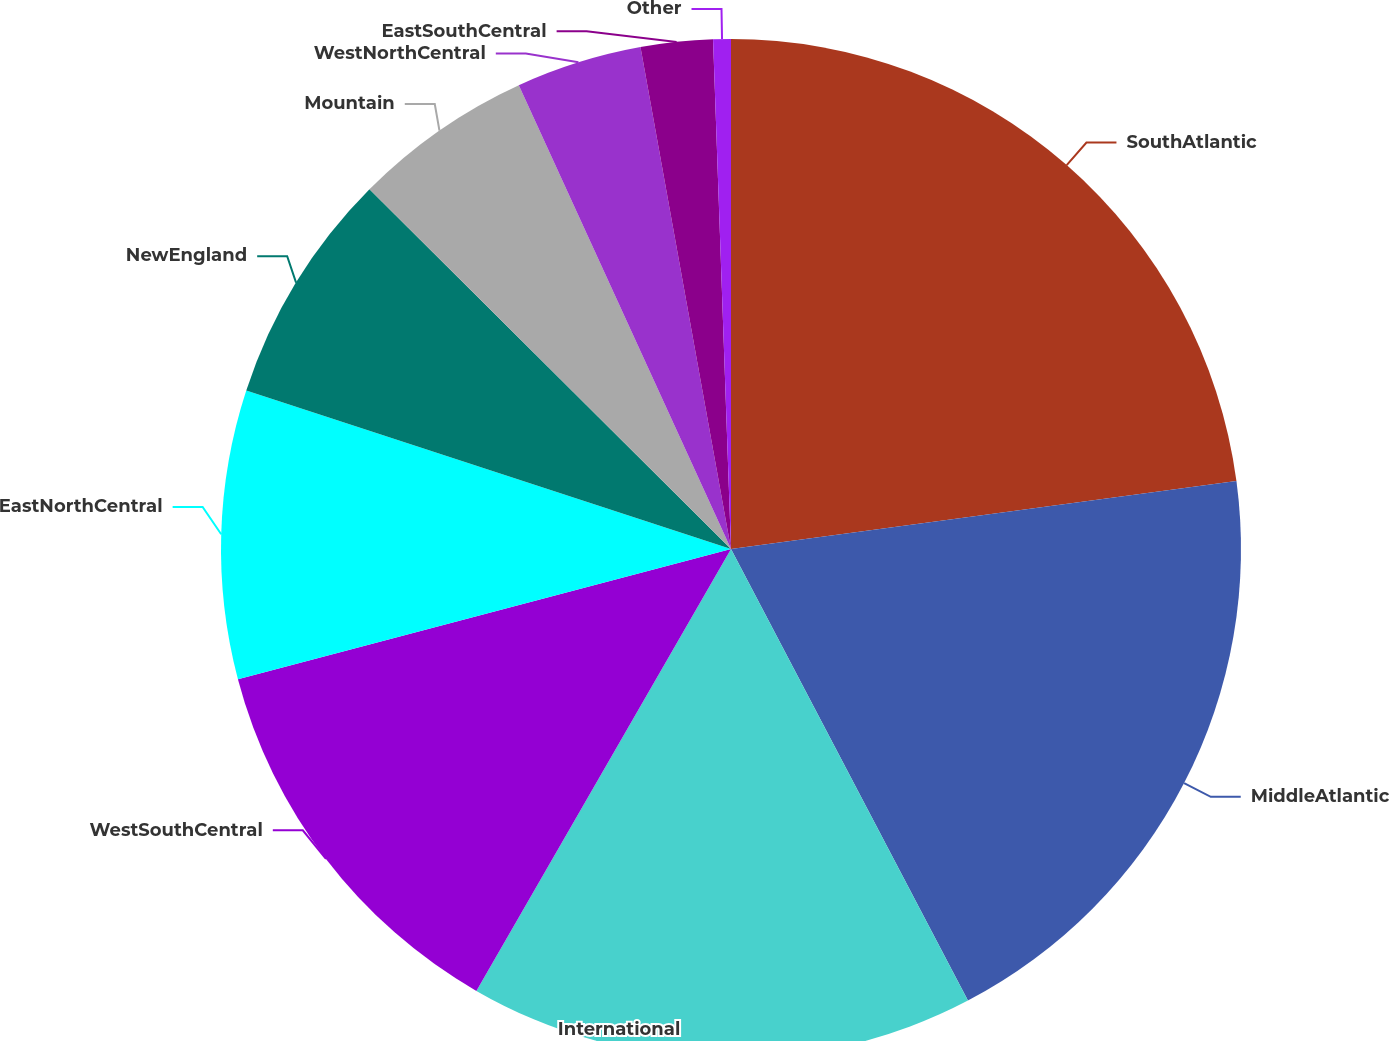<chart> <loc_0><loc_0><loc_500><loc_500><pie_chart><fcel>SouthAtlantic<fcel>MiddleAtlantic<fcel>International<fcel>WestSouthCentral<fcel>EastNorthCentral<fcel>NewEngland<fcel>Mountain<fcel>WestNorthCentral<fcel>EastSouthCentral<fcel>Other<nl><fcel>22.87%<fcel>19.44%<fcel>16.01%<fcel>12.57%<fcel>9.14%<fcel>7.43%<fcel>5.71%<fcel>3.99%<fcel>2.28%<fcel>0.56%<nl></chart> 